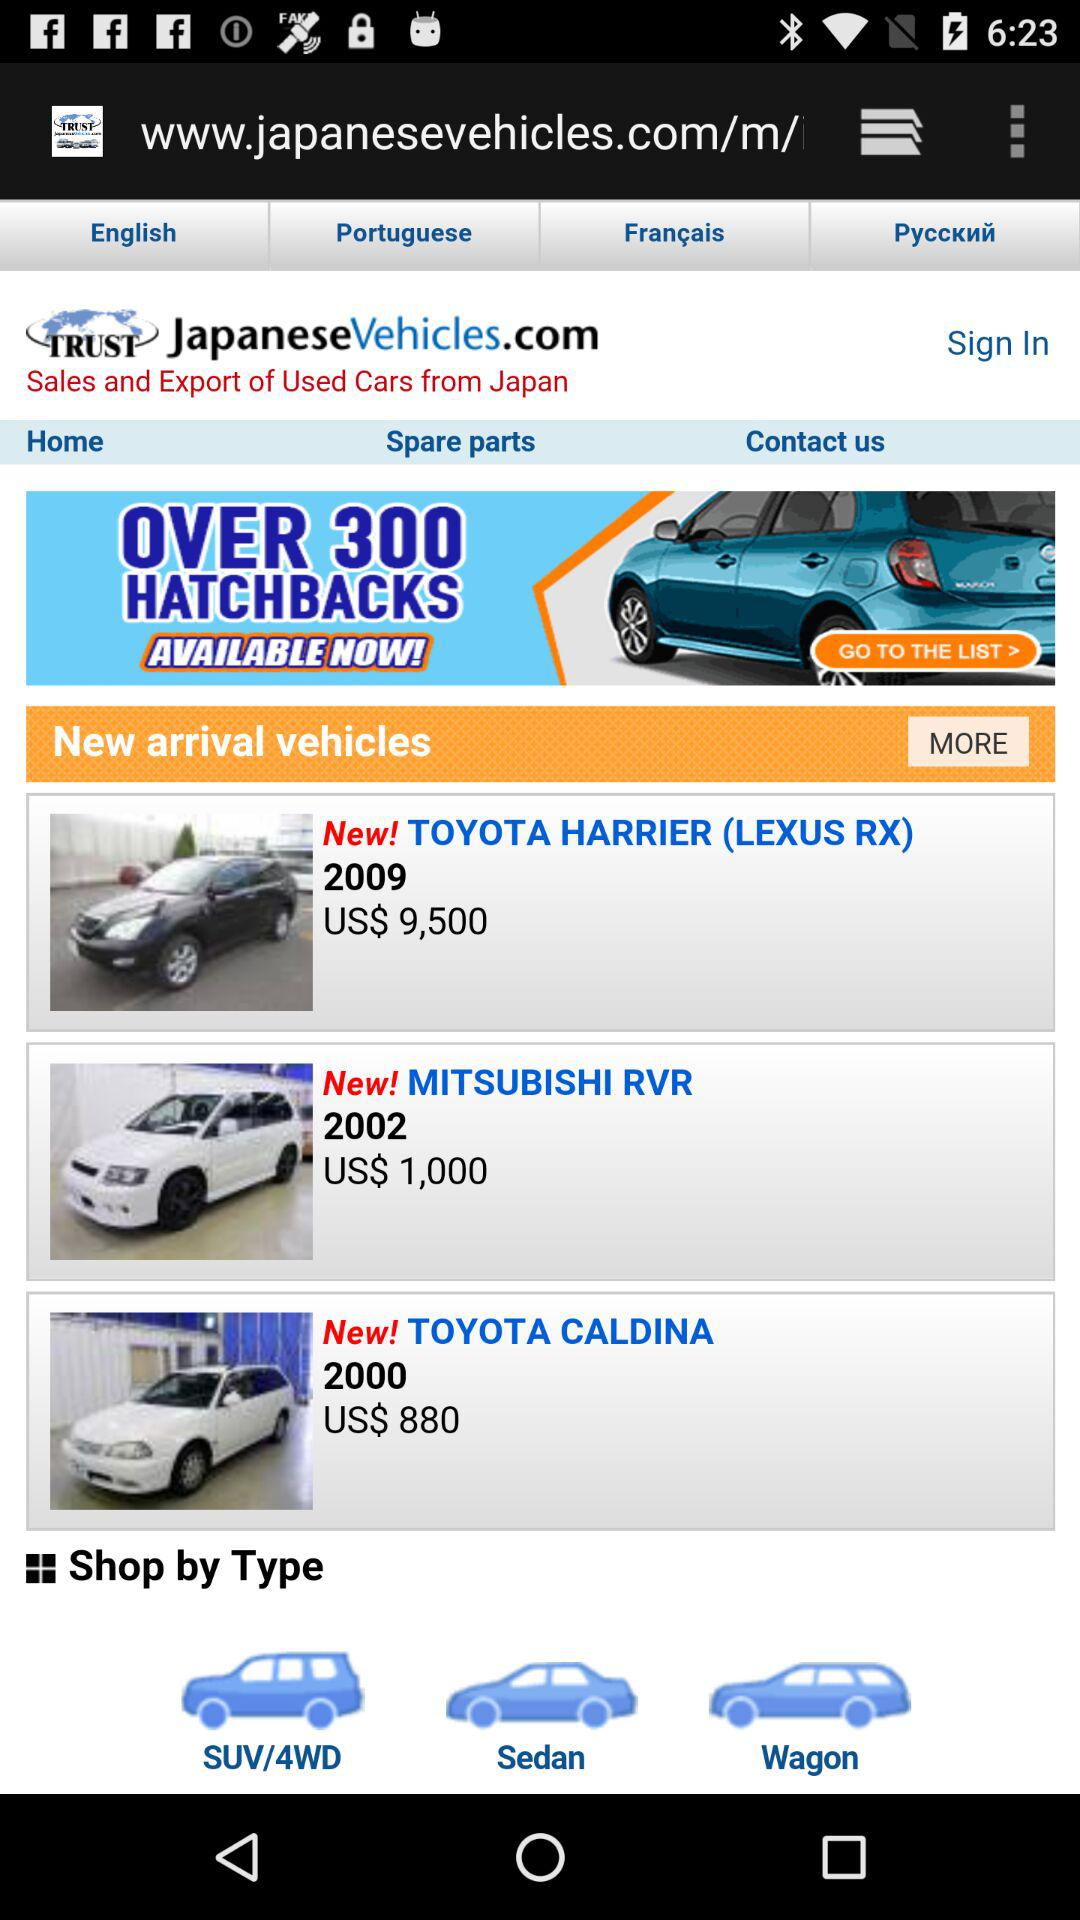What is the cost of the Mitsubishi RVR? The cost of the Mitsubishi RVR is US$1,000. 